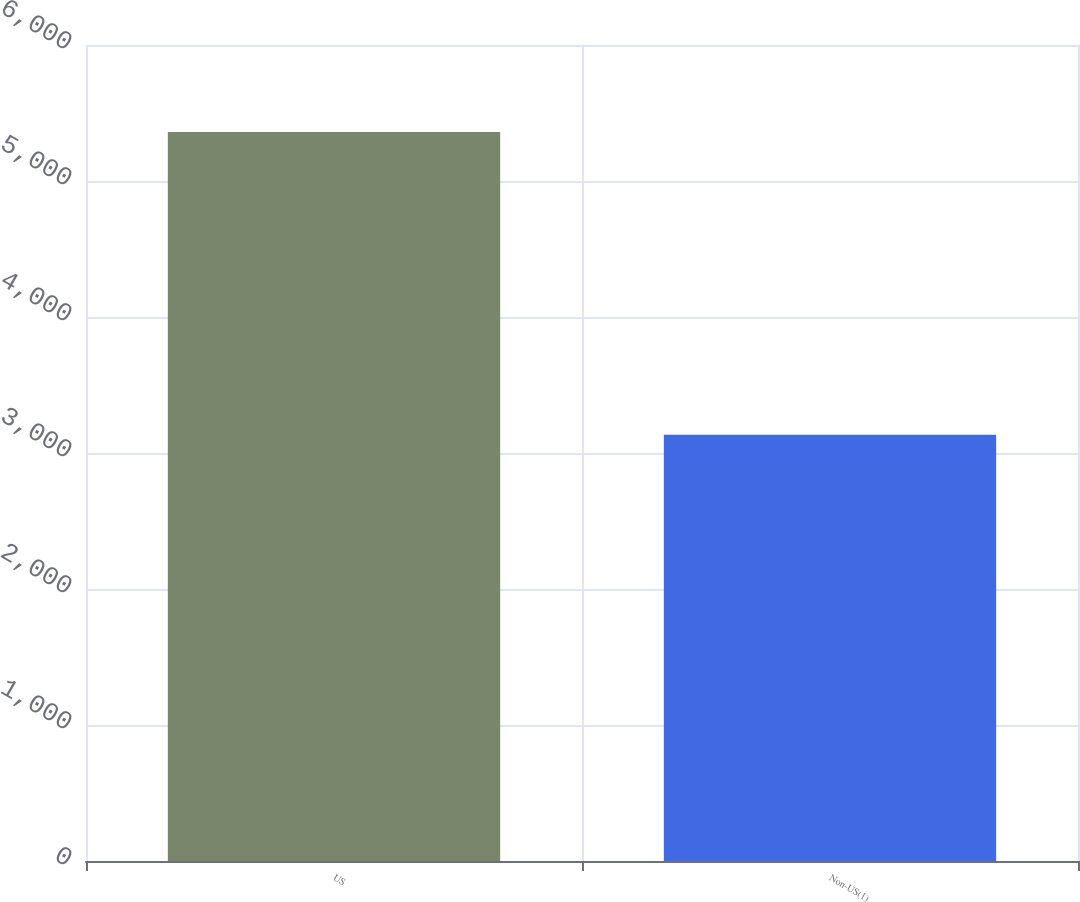<chart> <loc_0><loc_0><loc_500><loc_500><bar_chart><fcel>US<fcel>Non-US(1)<nl><fcel>5360<fcel>3135<nl></chart> 